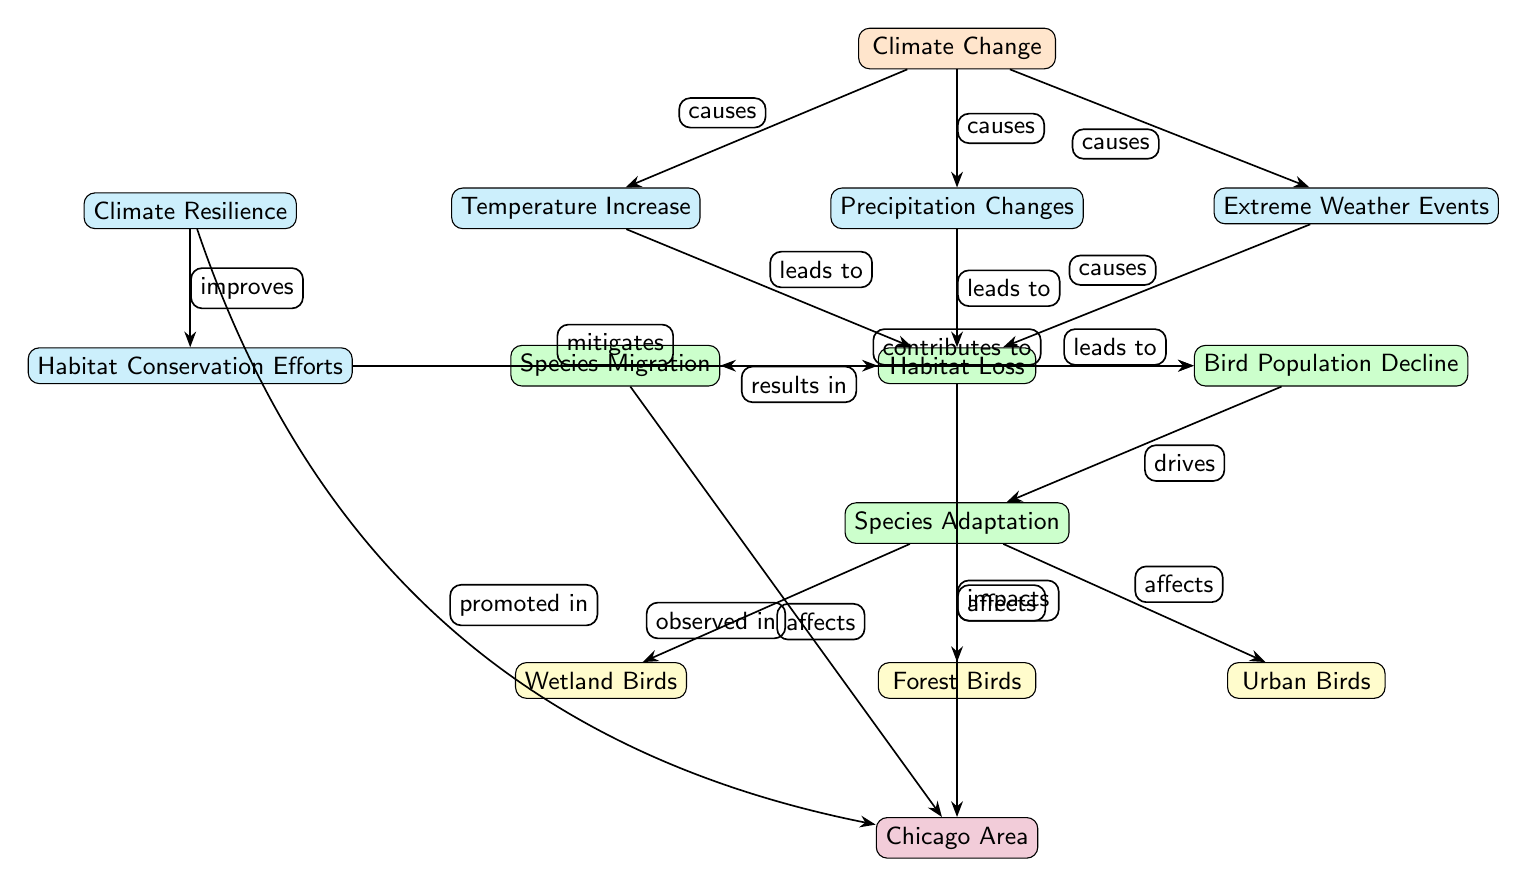What are the three main climate-related factors impacting birds? The diagram lists three main climate-related factors under the "Climate Change" node, which are "Temperature Increase," "Precipitation Changes," and "Extreme Weather Events."
Answer: Temperature Increase, Precipitation Changes, Extreme Weather Events What type of birds are affected by species adaptation? The "Species Adaptation" node connects to three types of birds: "Wetland Birds," "Forest Birds," and "Urban Birds." These specify the categories impacted by adaptation strategies due to changing habitats.
Answer: Wetland Birds, Forest Birds, Urban Birds How many edges lead from the "Habitat" node? The "Habitat" node has three edges connecting it to the "Species Migration" node, the "Bird Population Decline" node, and the "Chicago Area" node. Counting these edges shows the impact and consequence of habitat change.
Answer: 3 What effect does habitat loss have on bird populations? The diagram shows that "Habitat Loss" leads to both "Species Migration" and "Bird Population Decline." Therefore, habitat loss is directly linked to these two outcomes.
Answer: Species Migration, Bird Population Decline Which node mitigates the effects on habitat? The diagram indicates that the "Habitat Conservation Efforts" node mitigates the impacts from "Habitat Loss." It shows a direct relationship emphasizing the role of conservation in protecting habitats.
Answer: Habitat Conservation Efforts What results from the adaptation of species according to the diagram? According to the diagram, "Species Adaptation" results in impacts on "Wetland Birds," "Forest Birds," and "Urban Birds." This shows how adaptation strategies are specifically directed towards different types of birds in response to climate change.
Answer: Wetland Birds, Forest Birds, Urban Birds How is climate resilience promoted in the Chicago area? The diagram illustrates that "Climate Resilience" leads to "Habitat Conservation Efforts," and then those efforts impact habitat. This chain emphasizes how resilience strategies positively affect conservation actions in the Chicago area.
Answer: Habitat Conservation Efforts Which concept drives species adaptation? The "Bird Population Decline" node drives the "Species Adaptation" node, indicating that declining populations are motivating species to adapt to changing conditions. Thus, the decline influences adaptation directly.
Answer: Bird Population Decline 